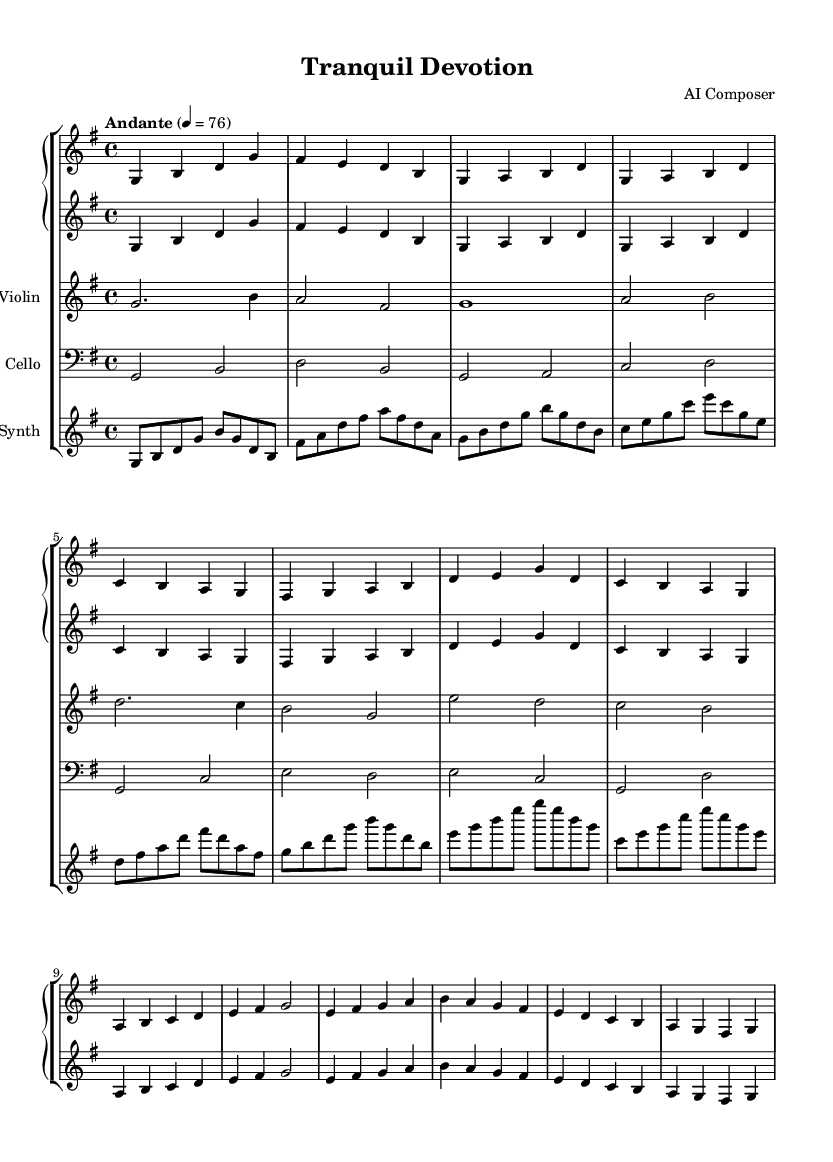What is the key signature of this music? The key signature is indicated at the beginning of the score. The presence of one sharp, which is F sharp, indicates that the key signature is G major.
Answer: G major What is the time signature of this music? The time signature is located at the beginning of the score, next to the key signature. It shows 4 over 4, which means there are four beats in each measure and the quarter note gets one beat.
Answer: 4/4 What is the tempo marking in this piece? The tempo marking is found at the beginning above the staff. It states "Andante" followed by a metronome marking of 76, indicating a moderately slow tempo.
Answer: Andante 76 How many different instruments are included in this score? By analyzing the score layout, we can see that there are four different parts: Piano, Violin, Cello, and Synth, indicating four instruments involved in the piece.
Answer: Four Which instrument has a clef that reads bass? In the score, the Cello part is specified with a bass clef. This clef is used for lower-pitched instruments, such as the cello, to indicate which notes are played.
Answer: Cello What is the highest note played in the piece? By examining the piano part as well as the violin part, the highest note is identified as 'g' in the second octave, shown as the highest pitch in the given measures.
Answer: g Which part appears to play the melody most prominently? The Violin part is structured to have longer values and more sustained notes compared to the underlying harmonies, indicating it carries the melodic line throughout the piece.
Answer: Violin 